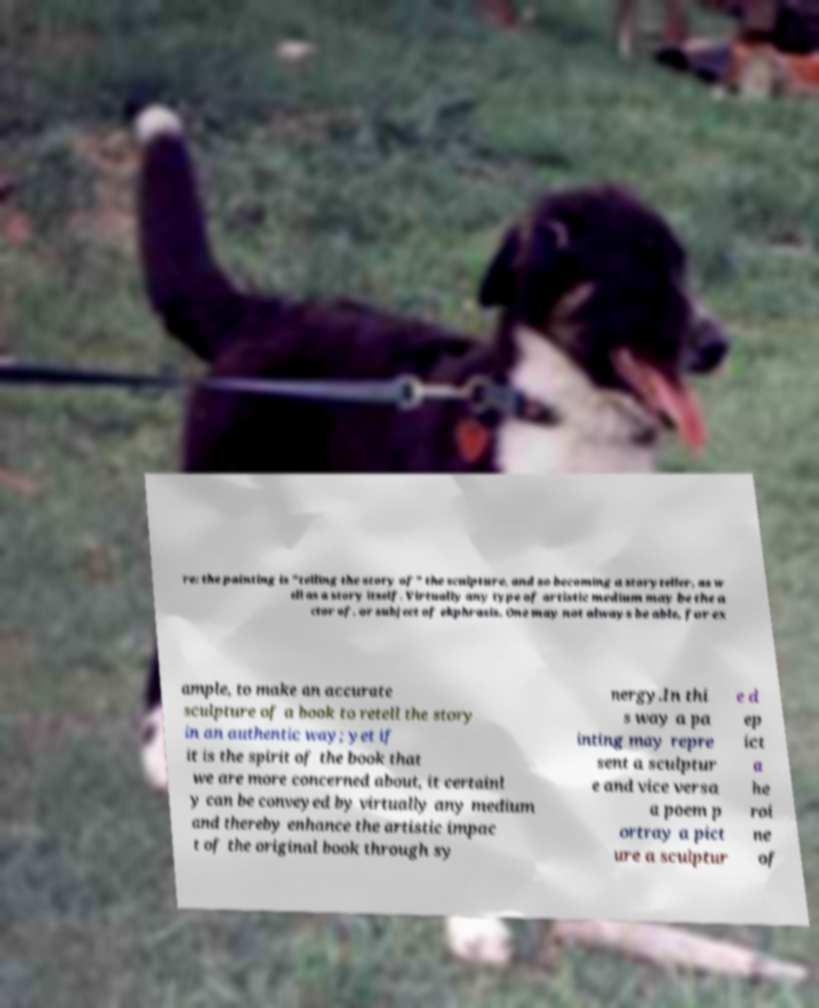I need the written content from this picture converted into text. Can you do that? re: the painting is "telling the story of" the sculpture, and so becoming a storyteller, as w ell as a story itself. Virtually any type of artistic medium may be the a ctor of, or subject of ekphrasis. One may not always be able, for ex ample, to make an accurate sculpture of a book to retell the story in an authentic way; yet if it is the spirit of the book that we are more concerned about, it certainl y can be conveyed by virtually any medium and thereby enhance the artistic impac t of the original book through sy nergy.In thi s way a pa inting may repre sent a sculptur e and vice versa a poem p ortray a pict ure a sculptur e d ep ict a he roi ne of 